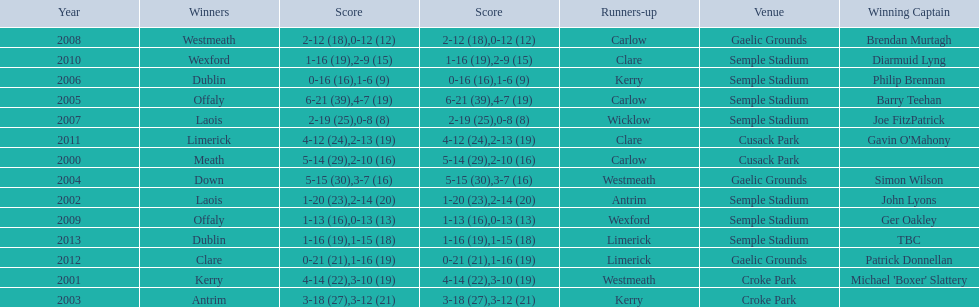Who was the first winner in 2013? Dublin. 